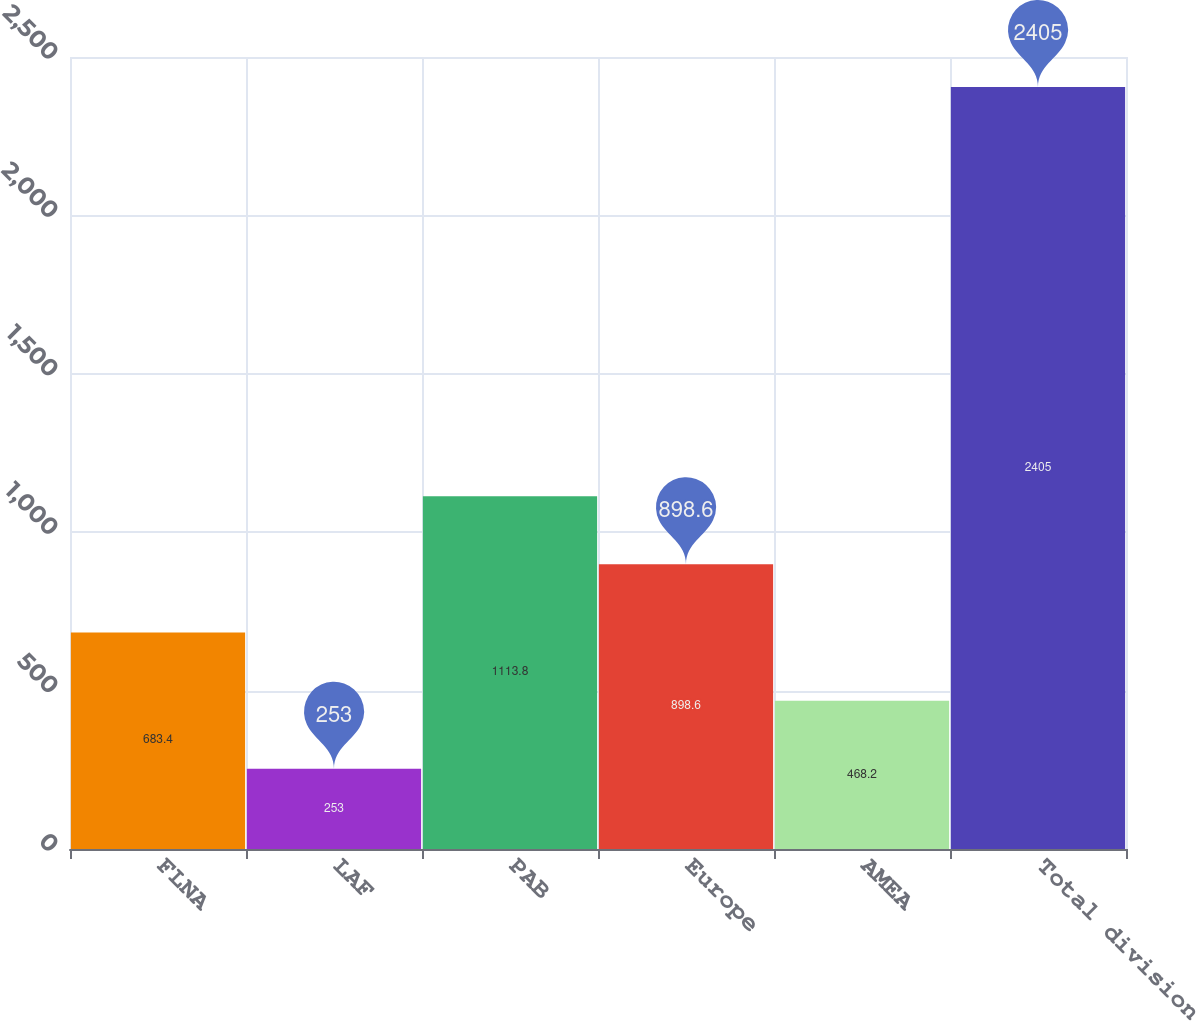Convert chart. <chart><loc_0><loc_0><loc_500><loc_500><bar_chart><fcel>FLNA<fcel>LAF<fcel>PAB<fcel>Europe<fcel>AMEA<fcel>Total division<nl><fcel>683.4<fcel>253<fcel>1113.8<fcel>898.6<fcel>468.2<fcel>2405<nl></chart> 